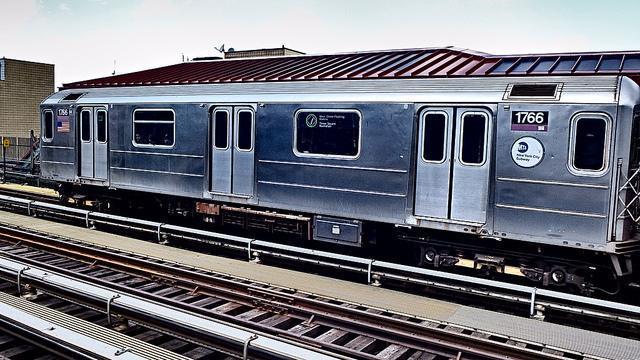How many doors are visible on the train?
Give a very brief answer. 6. 